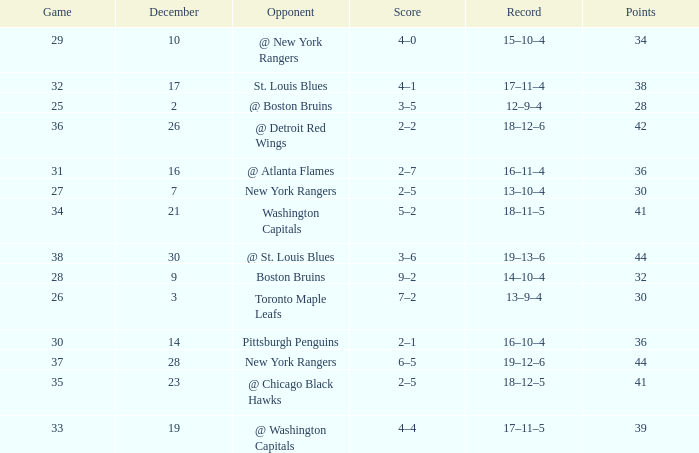Which Game has a Score of 4–1? 32.0. 